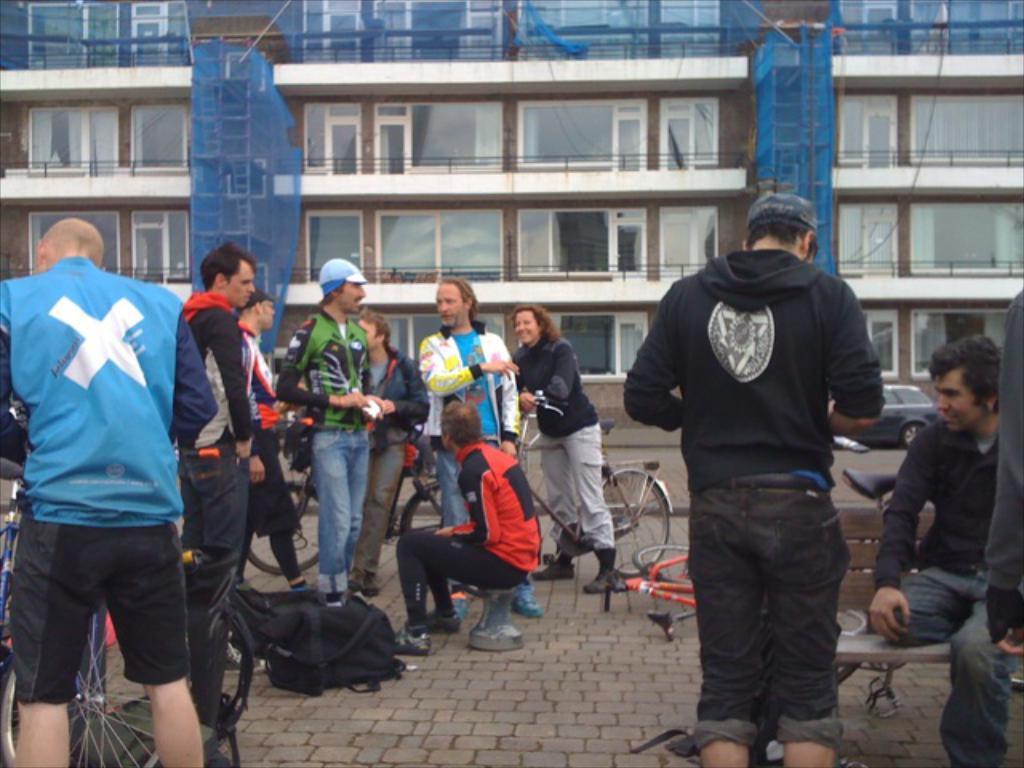How would you summarize this image in a sentence or two? This is the picture where we have a group of people Standing and some people riding the bicycle and behind them there is a building. 